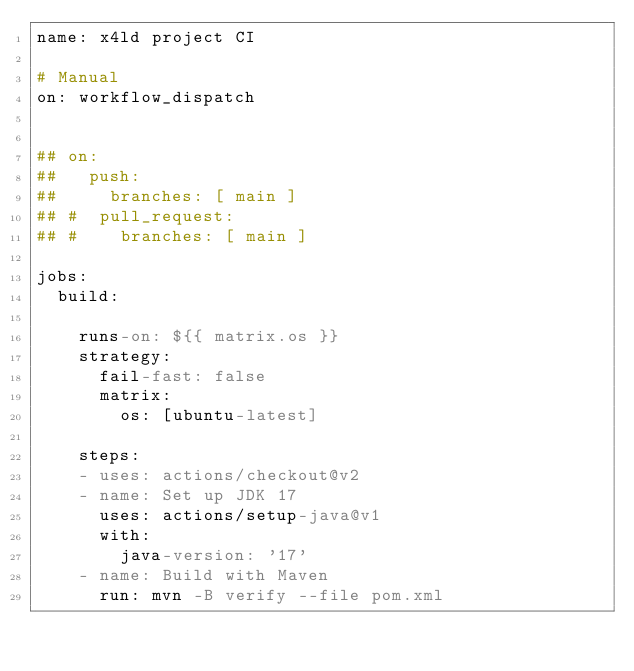Convert code to text. <code><loc_0><loc_0><loc_500><loc_500><_YAML_>name: x4ld project CI

# Manual
on: workflow_dispatch


## on:
##   push:
##     branches: [ main ]
## #  pull_request:
## #    branches: [ main ]

jobs:
  build:

    runs-on: ${{ matrix.os }}
    strategy:
      fail-fast: false
      matrix:
        os: [ubuntu-latest]
    
    steps:
    - uses: actions/checkout@v2
    - name: Set up JDK 17
      uses: actions/setup-java@v1
      with:
        java-version: '17'
    - name: Build with Maven
      run: mvn -B verify --file pom.xml
</code> 